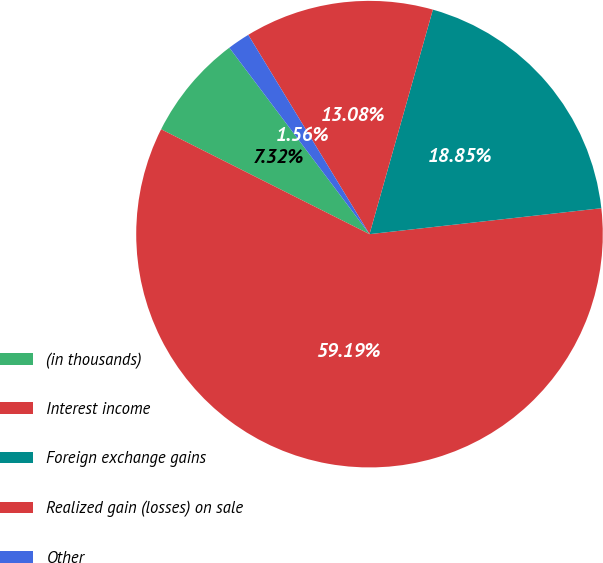<chart> <loc_0><loc_0><loc_500><loc_500><pie_chart><fcel>(in thousands)<fcel>Interest income<fcel>Foreign exchange gains<fcel>Realized gain (losses) on sale<fcel>Other<nl><fcel>7.32%<fcel>59.2%<fcel>18.85%<fcel>13.08%<fcel>1.56%<nl></chart> 